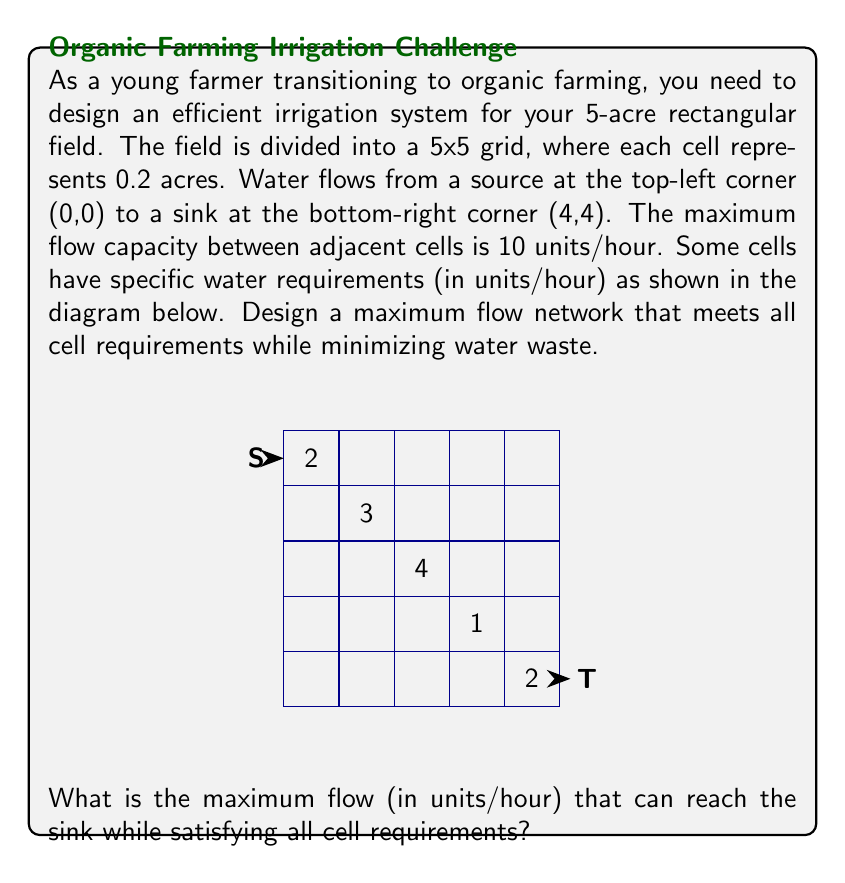Show me your answer to this math problem. To solve this problem, we'll use the Ford-Fulkerson algorithm for maximum flow networks. Here's a step-by-step approach:

1) First, we need to create a flow network that represents our field:
   - Each cell is a node in the network.
   - Edges connect adjacent cells with a capacity of 10 units/hour.
   - Cells with water requirements are represented as intermediate nodes with demands.

2) We'll use the Ford-Fulkerson algorithm to find the maximum flow from source (S) to sink (T).

3) Start with zero flow on all edges.

4) Find an augmenting path from S to T using depth-first search (DFS):
   S -> (0,0) -> (1,0) -> (2,0) -> (3,0) -> (4,0) -> (4,1) -> (4,2) -> (4,3) -> (4,4) -> T
   The bottleneck capacity of this path is 10 units/hour.

5) Augment the flow along this path by 10 units/hour.

6) Repeat steps 4-5 until no more augmenting paths can be found.

7) After several iterations, we'll reach the maximum flow configuration.

8) The final flow network will have:
   - 2 units/hour to the cell at (0,4)
   - 3 units/hour to the cell at (1,3)
   - 4 units/hour to the cell at (2,2)
   - 1 unit/hour to the cell at (3,1)
   - 2 units/hour to the cell at (4,0)

9) The maximum flow that reaches the sink (T) is the sum of all flows minus the intermediate demands:
   $$\text{Max Flow} = \text{Total Flow} - \text{Intermediate Demands}$$
   $$\text{Max Flow} = 22 - (2 + 3 + 4 + 1 + 2) = 22 - 12 = 10 \text{ units/hour}$$

Therefore, the maximum flow that can reach the sink while satisfying all cell requirements is 10 units/hour.
Answer: 10 units/hour 